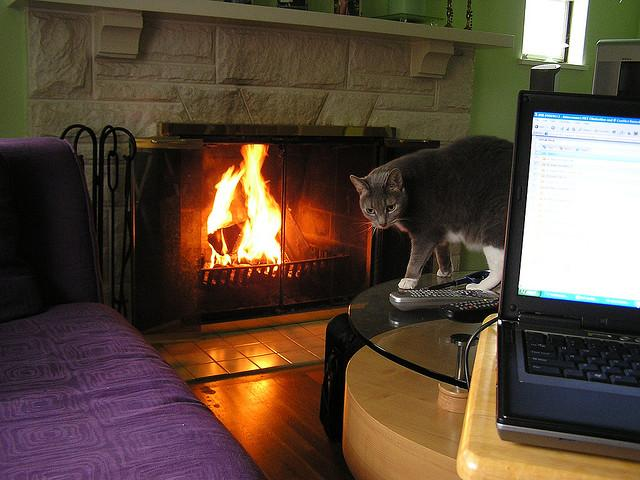What is creeping around on the table? Please explain your reasoning. cat. There is a feline with pointed ears and a tail. he is on top of a glass table. 